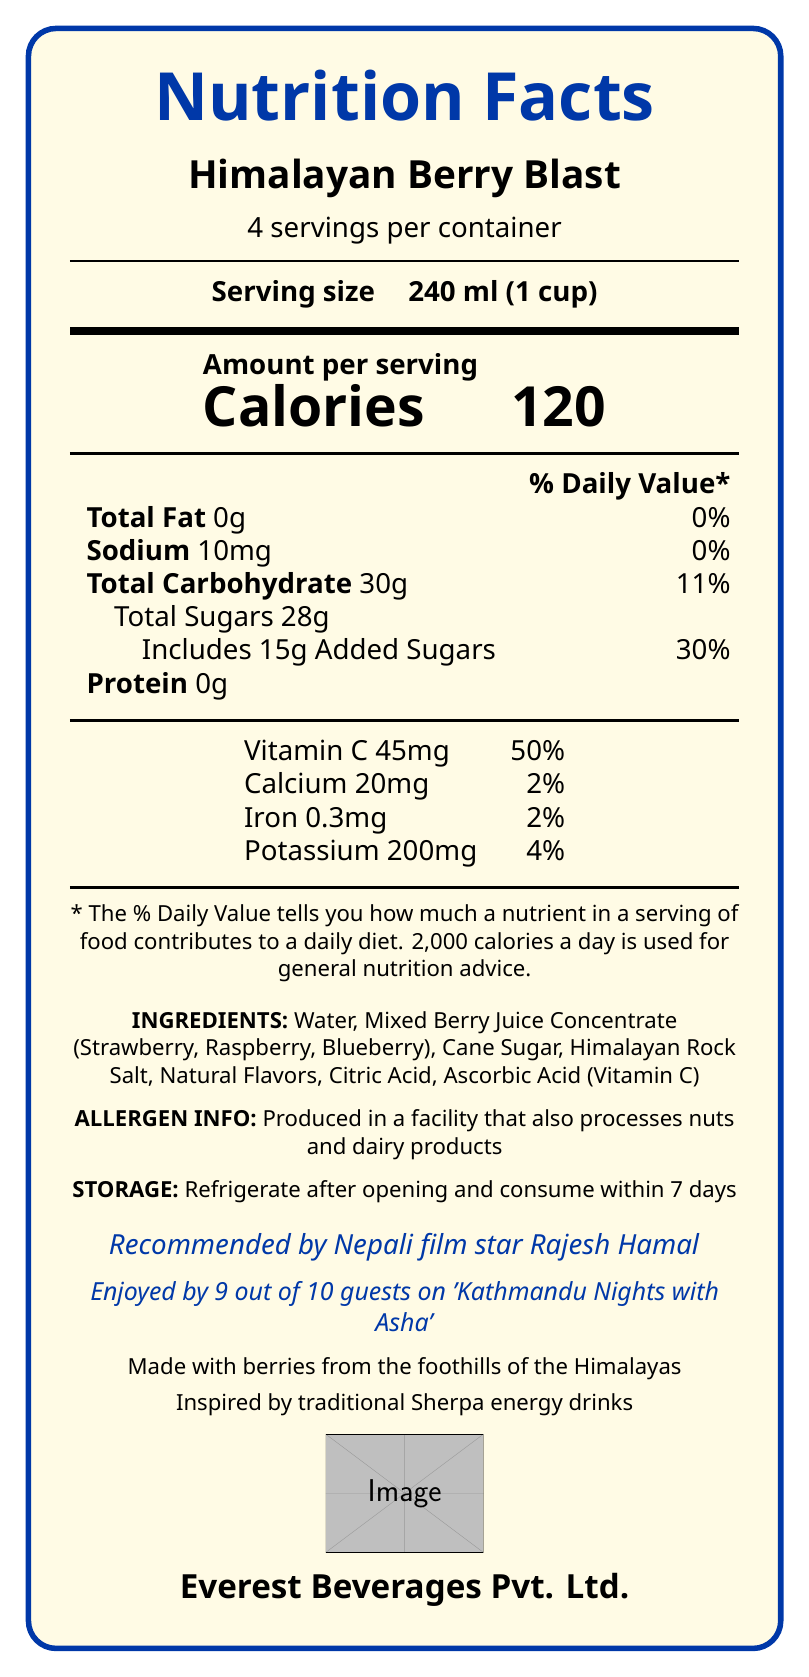what is the product name? The product name is clearly stated at the top of the document.
Answer: Himalayan Berry Blast who produces Himalayan Berry Blast? The manufacturer information is provided at the top and bottom part of the document.
Answer: Everest Beverages Pvt. Ltd. what is the serving size of Himalayan Berry Blast? The serving size is explicitly mentioned in the document.
Answer: 240 ml (1 cup) how many servings are there in one container of Himalayan Berry Blast? This information is mentioned below the product name, near the top of the document.
Answer: 4 servings per container what is the total calorie count per serving? The calorie count per serving is highlighted in large font under the “Amount per serving” section.
Answer: 120 Calories what is the percentage of daily value for total carbohydrates per serving? A. 5% B. 11% C. 20% D. 30% The daily value percentage for total carbohydrates is specified as 11% in the table.
Answer: B. 11% what kind of sugars are included in Himalayan Berry Blast, and how many grams are added sugars? The document mentions that the drink includes 15 grams of added sugars under the carbohydrate content.
Answer: Includes 15g Added Sugars how much Vitamin C does one serving of Himalayan Berry Blast provide? The amount of Vitamin C per serving is listed in the vitamins and minerals section.
Answer: 45mg (50% Daily Value) does Himalayan Berry Blast contain any protein? The document lists the protein content as 0g, indicating there is no protein.
Answer: No does this drink contain calcium? The document shows that the drink contains 20mg of calcium, which is 2% of the daily value.
Answer: Yes what should you do with the drink after opening it? The storage instructions specify to refrigerate after opening and consume within 7 days.
Answer: Refrigerate after opening and consume within 7 days is Himalayan Berry Blast produced in a nut-free facility? The allergen info states that it is produced in a facility that also processes nuts and dairy products.
Answer: No who endorses Himalayan Berry Blast? A. Rajesh Hamal B. Bhuwan Khatiwada C. Rekha Thapa The document mentions that the product is recommended by Nepali film star Rajesh Hamal.
Answer: A. Rajesh Hamal what traditional beverage inspired Himalayan Berry Blast? The document indicates that the drink is inspired by traditional Sherpa energy drinks.
Answer: Traditional Sherpa energy drinks is the product made with locally sourced ingredients? The document mentions that it is made with berries from the foothills of the Himalayas.
Answer: Yes can you determine the price of Himalayan Berry Blast from the document? The document does not provide any details on the price of the product.
Answer: Not enough information summarize the main information presented in the document. This summary captures all the key points from the nutrition facts label, including nutritional content, ingredients, storage instructions, endorsements, and cultural aspects.
Answer: The document is a nutrition facts label for Himalayan Berry Blast, a fruit juice produced by Everest Beverages Pvt. Ltd. Each serving size is 240ml, with 4 servings per container. The drink has 120 calories per serving and contains 0g of fat, 10mg of sodium, 30g of carbohydrates (with 28g total sugars including 15g added sugars), and 0g of protein. It provides significant amounts of Vitamin C (45mg, 50% DV) and smaller amounts of calcium, iron, and potassium. Ingredients include water, mixed berry juice concentrate, cane sugar, Himalayan rock salt, and other natural additives. The product should be refrigerated after opening and consumed within 7 days. It is endorsed by Nepali film star Rajesh Hamal and enjoyed by many guests on a popular local radio show. 